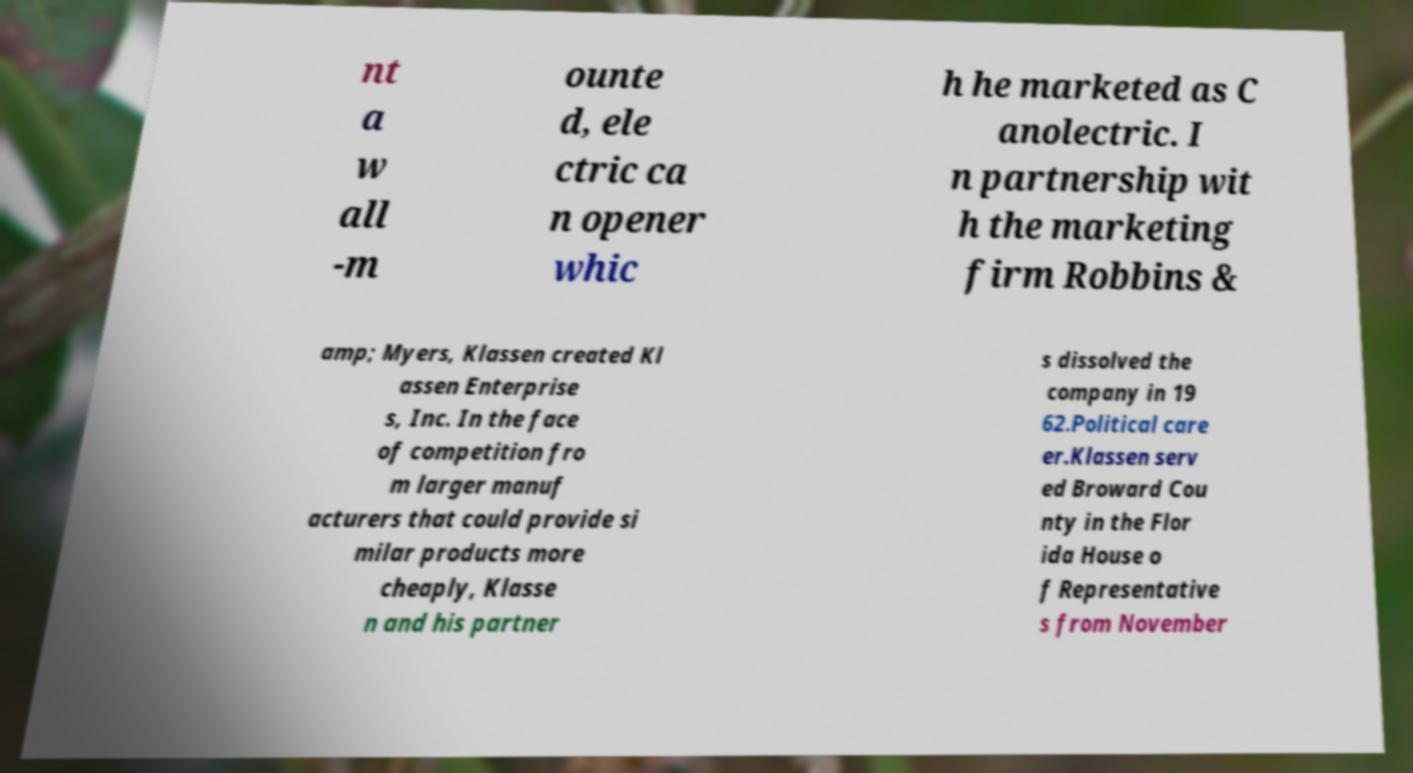Can you accurately transcribe the text from the provided image for me? nt a w all -m ounte d, ele ctric ca n opener whic h he marketed as C anolectric. I n partnership wit h the marketing firm Robbins & amp; Myers, Klassen created Kl assen Enterprise s, Inc. In the face of competition fro m larger manuf acturers that could provide si milar products more cheaply, Klasse n and his partner s dissolved the company in 19 62.Political care er.Klassen serv ed Broward Cou nty in the Flor ida House o f Representative s from November 